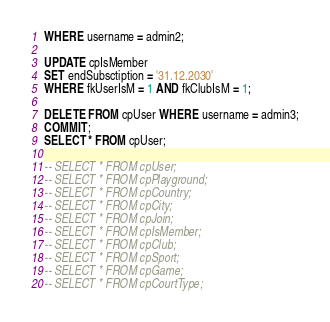<code> <loc_0><loc_0><loc_500><loc_500><_SQL_>WHERE username = admin2;

UPDATE cpIsMember
SET endSubsctiption = '31.12.2030'
WHERE fkUserIsM = 1 AND fkClubIsM = 1;

DELETE FROM cpUser WHERE username = admin3;
COMMIT;
SELECT * FROM cpUser;

-- SELECT * FROM cpUser;
-- SELECT * FROM cpPlayground;
-- SELECT * FROM cpCountry;
-- SELECT * FROM cpCity;
-- SELECT * FROM cpJoin;
-- SELECT * FROM cpIsMember;
-- SELECT * FROM cpClub;
-- SELECT * FROM cpSport;
-- SELECT * FROM cpGame;
-- SELECT * FROM cpCourtType;
</code> 